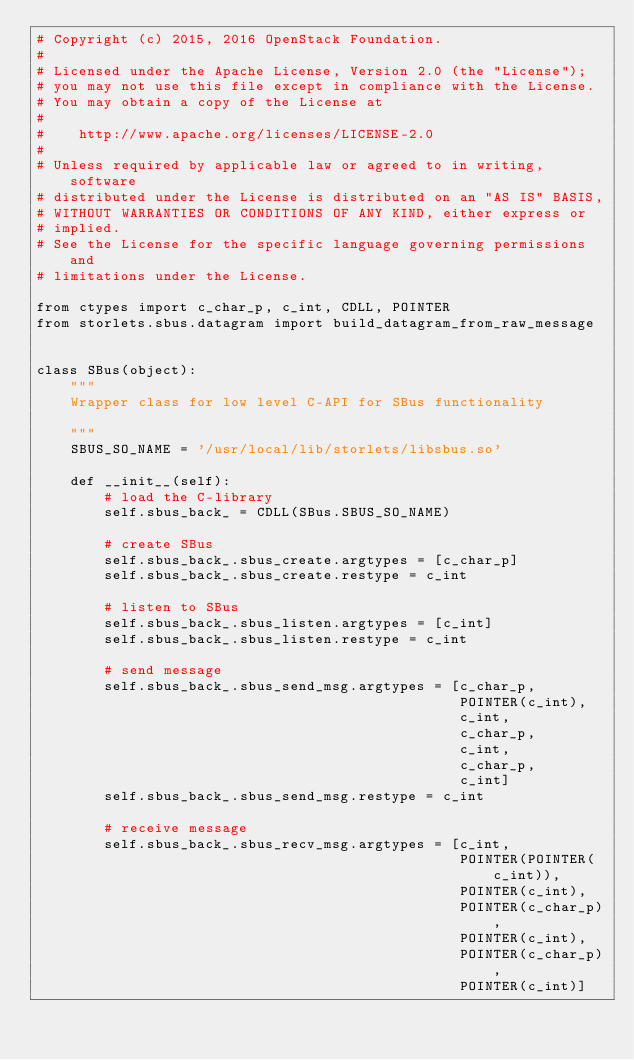<code> <loc_0><loc_0><loc_500><loc_500><_Python_># Copyright (c) 2015, 2016 OpenStack Foundation.
#
# Licensed under the Apache License, Version 2.0 (the "License");
# you may not use this file except in compliance with the License.
# You may obtain a copy of the License at
#
#    http://www.apache.org/licenses/LICENSE-2.0
#
# Unless required by applicable law or agreed to in writing, software
# distributed under the License is distributed on an "AS IS" BASIS,
# WITHOUT WARRANTIES OR CONDITIONS OF ANY KIND, either express or
# implied.
# See the License for the specific language governing permissions and
# limitations under the License.

from ctypes import c_char_p, c_int, CDLL, POINTER
from storlets.sbus.datagram import build_datagram_from_raw_message


class SBus(object):
    """
    Wrapper class for low level C-API for SBus functionality

    """
    SBUS_SO_NAME = '/usr/local/lib/storlets/libsbus.so'

    def __init__(self):
        # load the C-library
        self.sbus_back_ = CDLL(SBus.SBUS_SO_NAME)

        # create SBus
        self.sbus_back_.sbus_create.argtypes = [c_char_p]
        self.sbus_back_.sbus_create.restype = c_int

        # listen to SBus
        self.sbus_back_.sbus_listen.argtypes = [c_int]
        self.sbus_back_.sbus_listen.restype = c_int

        # send message
        self.sbus_back_.sbus_send_msg.argtypes = [c_char_p,
                                                  POINTER(c_int),
                                                  c_int,
                                                  c_char_p,
                                                  c_int,
                                                  c_char_p,
                                                  c_int]
        self.sbus_back_.sbus_send_msg.restype = c_int

        # receive message
        self.sbus_back_.sbus_recv_msg.argtypes = [c_int,
                                                  POINTER(POINTER(c_int)),
                                                  POINTER(c_int),
                                                  POINTER(c_char_p),
                                                  POINTER(c_int),
                                                  POINTER(c_char_p),
                                                  POINTER(c_int)]</code> 